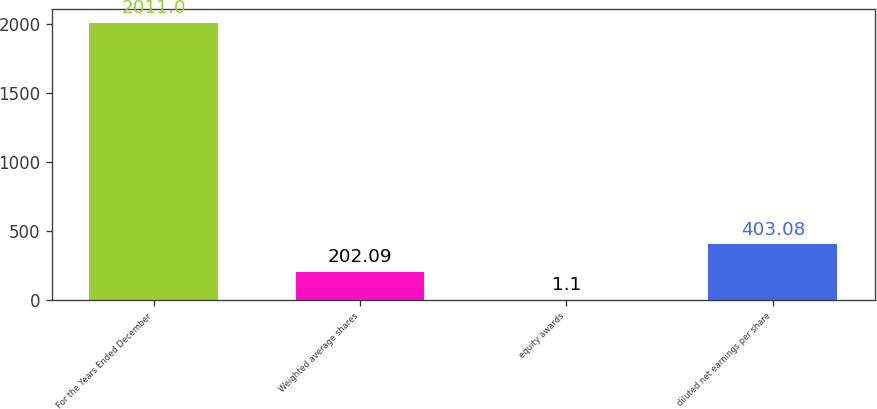Convert chart to OTSL. <chart><loc_0><loc_0><loc_500><loc_500><bar_chart><fcel>For the Years Ended December<fcel>Weighted average shares<fcel>equity awards<fcel>diluted net earnings per share<nl><fcel>2011<fcel>202.09<fcel>1.1<fcel>403.08<nl></chart> 